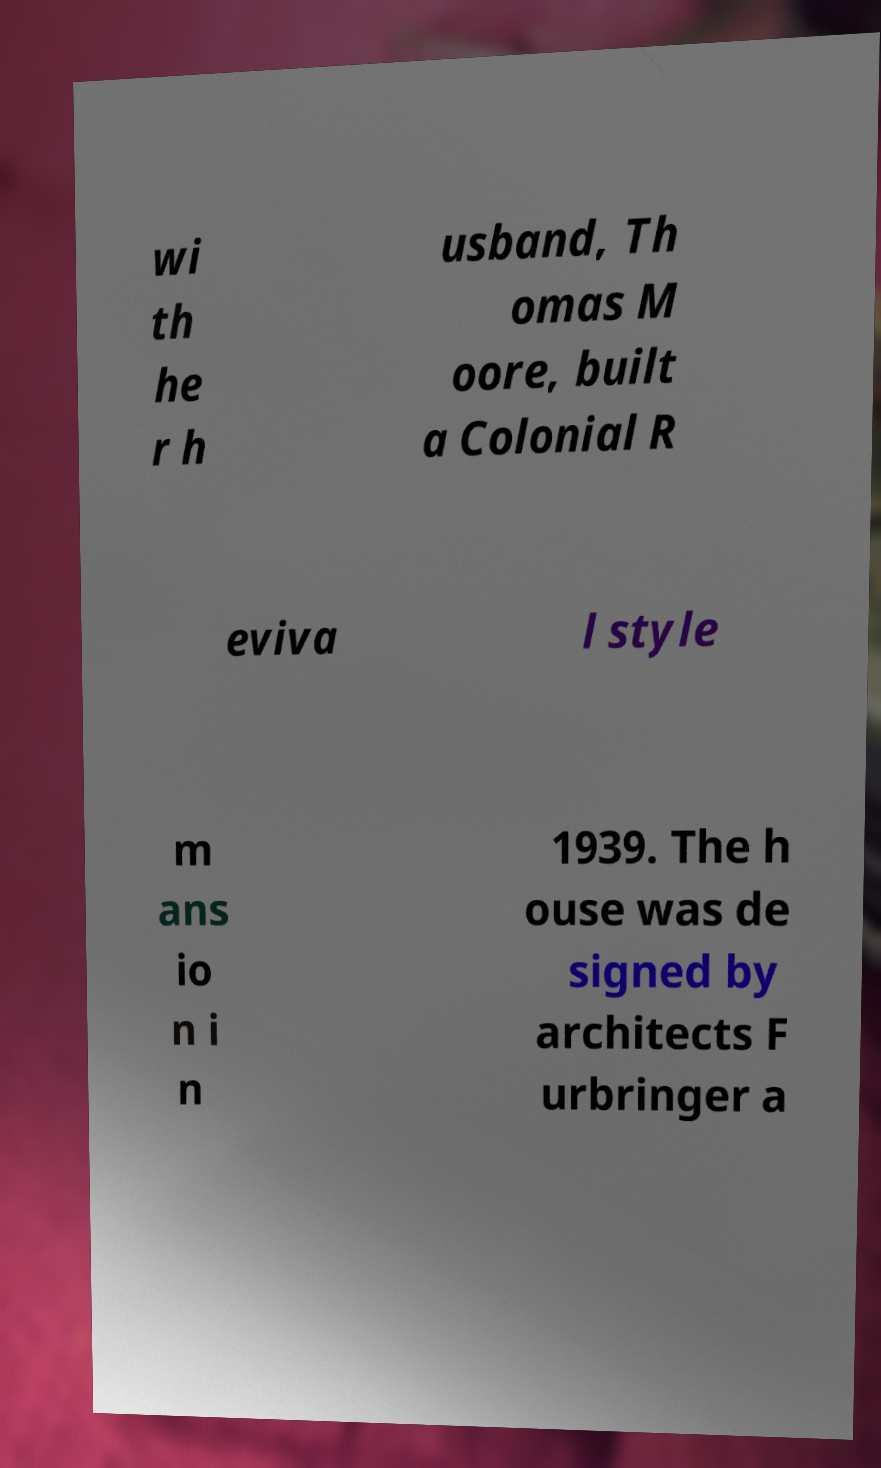Can you accurately transcribe the text from the provided image for me? wi th he r h usband, Th omas M oore, built a Colonial R eviva l style m ans io n i n 1939. The h ouse was de signed by architects F urbringer a 